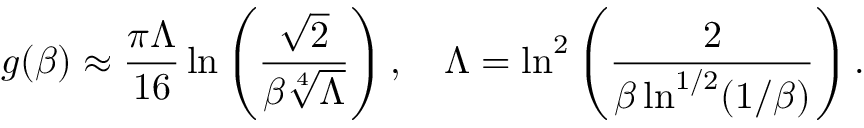Convert formula to latex. <formula><loc_0><loc_0><loc_500><loc_500>g ( \beta ) \approx \frac { \pi \Lambda } { 1 6 } \ln \left ( \frac { \sqrt { 2 } } { \beta \sqrt { [ } 4 ] { \Lambda } } \right ) , \quad \Lambda = \ln ^ { 2 } \left ( \frac { 2 } { \beta \ln ^ { 1 / 2 } ( 1 / \beta ) } \right ) .</formula> 